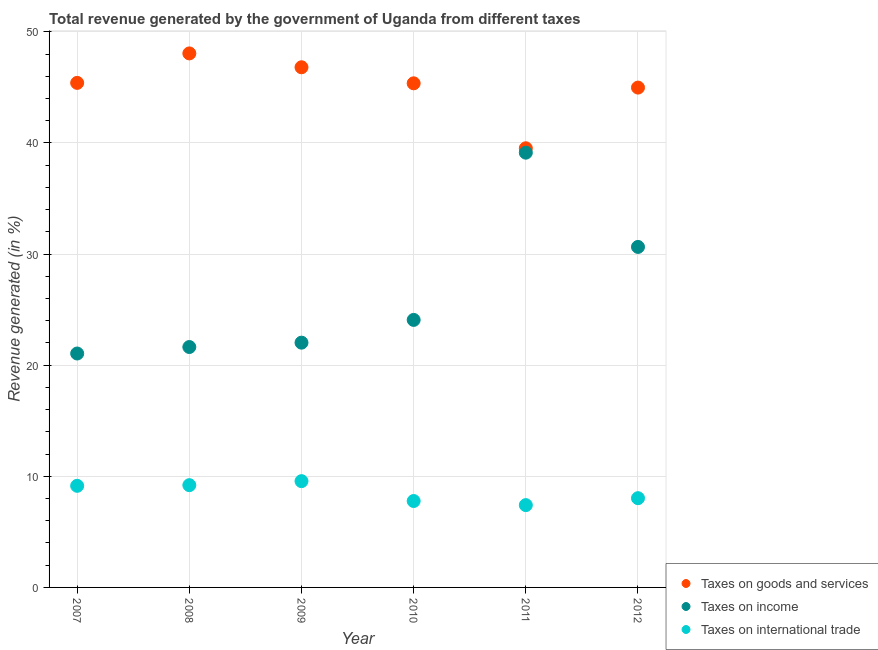Is the number of dotlines equal to the number of legend labels?
Provide a succinct answer. Yes. What is the percentage of revenue generated by taxes on income in 2010?
Make the answer very short. 24.07. Across all years, what is the maximum percentage of revenue generated by taxes on goods and services?
Offer a terse response. 48.06. Across all years, what is the minimum percentage of revenue generated by taxes on income?
Ensure brevity in your answer.  21.05. In which year was the percentage of revenue generated by taxes on income minimum?
Offer a very short reply. 2007. What is the total percentage of revenue generated by taxes on income in the graph?
Provide a succinct answer. 158.55. What is the difference between the percentage of revenue generated by taxes on income in 2007 and that in 2011?
Your answer should be compact. -18.07. What is the difference between the percentage of revenue generated by tax on international trade in 2011 and the percentage of revenue generated by taxes on goods and services in 2012?
Your answer should be compact. -37.57. What is the average percentage of revenue generated by tax on international trade per year?
Ensure brevity in your answer.  8.52. In the year 2010, what is the difference between the percentage of revenue generated by taxes on income and percentage of revenue generated by tax on international trade?
Your answer should be compact. 16.3. What is the ratio of the percentage of revenue generated by tax on international trade in 2007 to that in 2009?
Offer a terse response. 0.96. Is the percentage of revenue generated by taxes on goods and services in 2009 less than that in 2010?
Offer a terse response. No. Is the difference between the percentage of revenue generated by taxes on income in 2009 and 2011 greater than the difference between the percentage of revenue generated by tax on international trade in 2009 and 2011?
Ensure brevity in your answer.  No. What is the difference between the highest and the second highest percentage of revenue generated by tax on international trade?
Offer a terse response. 0.36. What is the difference between the highest and the lowest percentage of revenue generated by taxes on goods and services?
Provide a succinct answer. 8.54. In how many years, is the percentage of revenue generated by tax on international trade greater than the average percentage of revenue generated by tax on international trade taken over all years?
Your response must be concise. 3. Is it the case that in every year, the sum of the percentage of revenue generated by taxes on goods and services and percentage of revenue generated by taxes on income is greater than the percentage of revenue generated by tax on international trade?
Ensure brevity in your answer.  Yes. Does the percentage of revenue generated by taxes on income monotonically increase over the years?
Provide a short and direct response. No. Is the percentage of revenue generated by tax on international trade strictly greater than the percentage of revenue generated by taxes on income over the years?
Provide a succinct answer. No. Is the percentage of revenue generated by taxes on goods and services strictly less than the percentage of revenue generated by taxes on income over the years?
Offer a very short reply. No. How many dotlines are there?
Provide a short and direct response. 3. How many years are there in the graph?
Provide a short and direct response. 6. Does the graph contain any zero values?
Provide a short and direct response. No. Where does the legend appear in the graph?
Give a very brief answer. Bottom right. How are the legend labels stacked?
Keep it short and to the point. Vertical. What is the title of the graph?
Provide a short and direct response. Total revenue generated by the government of Uganda from different taxes. Does "Travel services" appear as one of the legend labels in the graph?
Your answer should be very brief. No. What is the label or title of the Y-axis?
Give a very brief answer. Revenue generated (in %). What is the Revenue generated (in %) of Taxes on goods and services in 2007?
Provide a succinct answer. 45.4. What is the Revenue generated (in %) in Taxes on income in 2007?
Make the answer very short. 21.05. What is the Revenue generated (in %) of Taxes on international trade in 2007?
Your response must be concise. 9.14. What is the Revenue generated (in %) of Taxes on goods and services in 2008?
Your answer should be very brief. 48.06. What is the Revenue generated (in %) in Taxes on income in 2008?
Offer a terse response. 21.63. What is the Revenue generated (in %) of Taxes on international trade in 2008?
Provide a succinct answer. 9.2. What is the Revenue generated (in %) of Taxes on goods and services in 2009?
Make the answer very short. 46.81. What is the Revenue generated (in %) of Taxes on income in 2009?
Offer a terse response. 22.03. What is the Revenue generated (in %) in Taxes on international trade in 2009?
Keep it short and to the point. 9.56. What is the Revenue generated (in %) of Taxes on goods and services in 2010?
Provide a short and direct response. 45.36. What is the Revenue generated (in %) in Taxes on income in 2010?
Provide a succinct answer. 24.07. What is the Revenue generated (in %) of Taxes on international trade in 2010?
Keep it short and to the point. 7.78. What is the Revenue generated (in %) of Taxes on goods and services in 2011?
Your answer should be compact. 39.52. What is the Revenue generated (in %) of Taxes on income in 2011?
Ensure brevity in your answer.  39.12. What is the Revenue generated (in %) in Taxes on international trade in 2011?
Ensure brevity in your answer.  7.41. What is the Revenue generated (in %) in Taxes on goods and services in 2012?
Provide a succinct answer. 44.98. What is the Revenue generated (in %) in Taxes on income in 2012?
Give a very brief answer. 30.64. What is the Revenue generated (in %) of Taxes on international trade in 2012?
Your response must be concise. 8.03. Across all years, what is the maximum Revenue generated (in %) of Taxes on goods and services?
Make the answer very short. 48.06. Across all years, what is the maximum Revenue generated (in %) in Taxes on income?
Your answer should be compact. 39.12. Across all years, what is the maximum Revenue generated (in %) of Taxes on international trade?
Your response must be concise. 9.56. Across all years, what is the minimum Revenue generated (in %) of Taxes on goods and services?
Your answer should be compact. 39.52. Across all years, what is the minimum Revenue generated (in %) in Taxes on income?
Your response must be concise. 21.05. Across all years, what is the minimum Revenue generated (in %) of Taxes on international trade?
Keep it short and to the point. 7.41. What is the total Revenue generated (in %) of Taxes on goods and services in the graph?
Offer a terse response. 270.13. What is the total Revenue generated (in %) in Taxes on income in the graph?
Offer a terse response. 158.55. What is the total Revenue generated (in %) of Taxes on international trade in the graph?
Ensure brevity in your answer.  51.12. What is the difference between the Revenue generated (in %) in Taxes on goods and services in 2007 and that in 2008?
Provide a short and direct response. -2.65. What is the difference between the Revenue generated (in %) in Taxes on income in 2007 and that in 2008?
Make the answer very short. -0.58. What is the difference between the Revenue generated (in %) in Taxes on international trade in 2007 and that in 2008?
Offer a terse response. -0.06. What is the difference between the Revenue generated (in %) of Taxes on goods and services in 2007 and that in 2009?
Provide a short and direct response. -1.4. What is the difference between the Revenue generated (in %) in Taxes on income in 2007 and that in 2009?
Give a very brief answer. -0.98. What is the difference between the Revenue generated (in %) of Taxes on international trade in 2007 and that in 2009?
Give a very brief answer. -0.42. What is the difference between the Revenue generated (in %) in Taxes on goods and services in 2007 and that in 2010?
Offer a terse response. 0.04. What is the difference between the Revenue generated (in %) in Taxes on income in 2007 and that in 2010?
Offer a very short reply. -3.02. What is the difference between the Revenue generated (in %) of Taxes on international trade in 2007 and that in 2010?
Provide a short and direct response. 1.37. What is the difference between the Revenue generated (in %) in Taxes on goods and services in 2007 and that in 2011?
Your answer should be compact. 5.89. What is the difference between the Revenue generated (in %) of Taxes on income in 2007 and that in 2011?
Offer a very short reply. -18.07. What is the difference between the Revenue generated (in %) in Taxes on international trade in 2007 and that in 2011?
Your answer should be very brief. 1.74. What is the difference between the Revenue generated (in %) in Taxes on goods and services in 2007 and that in 2012?
Ensure brevity in your answer.  0.42. What is the difference between the Revenue generated (in %) in Taxes on income in 2007 and that in 2012?
Offer a terse response. -9.59. What is the difference between the Revenue generated (in %) of Taxes on international trade in 2007 and that in 2012?
Provide a succinct answer. 1.11. What is the difference between the Revenue generated (in %) of Taxes on goods and services in 2008 and that in 2009?
Provide a short and direct response. 1.25. What is the difference between the Revenue generated (in %) in Taxes on income in 2008 and that in 2009?
Offer a very short reply. -0.39. What is the difference between the Revenue generated (in %) of Taxes on international trade in 2008 and that in 2009?
Your answer should be compact. -0.36. What is the difference between the Revenue generated (in %) in Taxes on goods and services in 2008 and that in 2010?
Your answer should be compact. 2.69. What is the difference between the Revenue generated (in %) in Taxes on income in 2008 and that in 2010?
Keep it short and to the point. -2.44. What is the difference between the Revenue generated (in %) of Taxes on international trade in 2008 and that in 2010?
Provide a succinct answer. 1.43. What is the difference between the Revenue generated (in %) in Taxes on goods and services in 2008 and that in 2011?
Offer a terse response. 8.54. What is the difference between the Revenue generated (in %) in Taxes on income in 2008 and that in 2011?
Your answer should be very brief. -17.49. What is the difference between the Revenue generated (in %) of Taxes on international trade in 2008 and that in 2011?
Offer a very short reply. 1.8. What is the difference between the Revenue generated (in %) of Taxes on goods and services in 2008 and that in 2012?
Offer a terse response. 3.08. What is the difference between the Revenue generated (in %) in Taxes on income in 2008 and that in 2012?
Offer a terse response. -9.01. What is the difference between the Revenue generated (in %) of Taxes on international trade in 2008 and that in 2012?
Provide a succinct answer. 1.17. What is the difference between the Revenue generated (in %) in Taxes on goods and services in 2009 and that in 2010?
Provide a succinct answer. 1.44. What is the difference between the Revenue generated (in %) in Taxes on income in 2009 and that in 2010?
Provide a short and direct response. -2.05. What is the difference between the Revenue generated (in %) in Taxes on international trade in 2009 and that in 2010?
Give a very brief answer. 1.79. What is the difference between the Revenue generated (in %) in Taxes on goods and services in 2009 and that in 2011?
Provide a short and direct response. 7.29. What is the difference between the Revenue generated (in %) of Taxes on income in 2009 and that in 2011?
Provide a short and direct response. -17.1. What is the difference between the Revenue generated (in %) in Taxes on international trade in 2009 and that in 2011?
Your response must be concise. 2.16. What is the difference between the Revenue generated (in %) in Taxes on goods and services in 2009 and that in 2012?
Give a very brief answer. 1.83. What is the difference between the Revenue generated (in %) of Taxes on income in 2009 and that in 2012?
Provide a succinct answer. -8.62. What is the difference between the Revenue generated (in %) of Taxes on international trade in 2009 and that in 2012?
Your response must be concise. 1.53. What is the difference between the Revenue generated (in %) in Taxes on goods and services in 2010 and that in 2011?
Offer a very short reply. 5.85. What is the difference between the Revenue generated (in %) in Taxes on income in 2010 and that in 2011?
Your answer should be very brief. -15.05. What is the difference between the Revenue generated (in %) in Taxes on international trade in 2010 and that in 2011?
Your response must be concise. 0.37. What is the difference between the Revenue generated (in %) in Taxes on goods and services in 2010 and that in 2012?
Provide a short and direct response. 0.38. What is the difference between the Revenue generated (in %) of Taxes on income in 2010 and that in 2012?
Provide a short and direct response. -6.57. What is the difference between the Revenue generated (in %) in Taxes on international trade in 2010 and that in 2012?
Ensure brevity in your answer.  -0.26. What is the difference between the Revenue generated (in %) of Taxes on goods and services in 2011 and that in 2012?
Provide a short and direct response. -5.46. What is the difference between the Revenue generated (in %) of Taxes on income in 2011 and that in 2012?
Keep it short and to the point. 8.48. What is the difference between the Revenue generated (in %) in Taxes on international trade in 2011 and that in 2012?
Your answer should be very brief. -0.62. What is the difference between the Revenue generated (in %) of Taxes on goods and services in 2007 and the Revenue generated (in %) of Taxes on income in 2008?
Provide a succinct answer. 23.77. What is the difference between the Revenue generated (in %) of Taxes on goods and services in 2007 and the Revenue generated (in %) of Taxes on international trade in 2008?
Ensure brevity in your answer.  36.2. What is the difference between the Revenue generated (in %) in Taxes on income in 2007 and the Revenue generated (in %) in Taxes on international trade in 2008?
Offer a very short reply. 11.85. What is the difference between the Revenue generated (in %) of Taxes on goods and services in 2007 and the Revenue generated (in %) of Taxes on income in 2009?
Your response must be concise. 23.38. What is the difference between the Revenue generated (in %) in Taxes on goods and services in 2007 and the Revenue generated (in %) in Taxes on international trade in 2009?
Ensure brevity in your answer.  35.84. What is the difference between the Revenue generated (in %) in Taxes on income in 2007 and the Revenue generated (in %) in Taxes on international trade in 2009?
Give a very brief answer. 11.49. What is the difference between the Revenue generated (in %) in Taxes on goods and services in 2007 and the Revenue generated (in %) in Taxes on income in 2010?
Your answer should be very brief. 21.33. What is the difference between the Revenue generated (in %) of Taxes on goods and services in 2007 and the Revenue generated (in %) of Taxes on international trade in 2010?
Keep it short and to the point. 37.63. What is the difference between the Revenue generated (in %) in Taxes on income in 2007 and the Revenue generated (in %) in Taxes on international trade in 2010?
Ensure brevity in your answer.  13.27. What is the difference between the Revenue generated (in %) of Taxes on goods and services in 2007 and the Revenue generated (in %) of Taxes on income in 2011?
Provide a short and direct response. 6.28. What is the difference between the Revenue generated (in %) in Taxes on goods and services in 2007 and the Revenue generated (in %) in Taxes on international trade in 2011?
Give a very brief answer. 38. What is the difference between the Revenue generated (in %) of Taxes on income in 2007 and the Revenue generated (in %) of Taxes on international trade in 2011?
Make the answer very short. 13.64. What is the difference between the Revenue generated (in %) of Taxes on goods and services in 2007 and the Revenue generated (in %) of Taxes on income in 2012?
Your answer should be very brief. 14.76. What is the difference between the Revenue generated (in %) of Taxes on goods and services in 2007 and the Revenue generated (in %) of Taxes on international trade in 2012?
Ensure brevity in your answer.  37.37. What is the difference between the Revenue generated (in %) of Taxes on income in 2007 and the Revenue generated (in %) of Taxes on international trade in 2012?
Give a very brief answer. 13.02. What is the difference between the Revenue generated (in %) of Taxes on goods and services in 2008 and the Revenue generated (in %) of Taxes on income in 2009?
Your answer should be compact. 26.03. What is the difference between the Revenue generated (in %) of Taxes on goods and services in 2008 and the Revenue generated (in %) of Taxes on international trade in 2009?
Your answer should be very brief. 38.49. What is the difference between the Revenue generated (in %) in Taxes on income in 2008 and the Revenue generated (in %) in Taxes on international trade in 2009?
Keep it short and to the point. 12.07. What is the difference between the Revenue generated (in %) of Taxes on goods and services in 2008 and the Revenue generated (in %) of Taxes on income in 2010?
Make the answer very short. 23.98. What is the difference between the Revenue generated (in %) in Taxes on goods and services in 2008 and the Revenue generated (in %) in Taxes on international trade in 2010?
Provide a short and direct response. 40.28. What is the difference between the Revenue generated (in %) of Taxes on income in 2008 and the Revenue generated (in %) of Taxes on international trade in 2010?
Ensure brevity in your answer.  13.86. What is the difference between the Revenue generated (in %) of Taxes on goods and services in 2008 and the Revenue generated (in %) of Taxes on income in 2011?
Offer a very short reply. 8.93. What is the difference between the Revenue generated (in %) of Taxes on goods and services in 2008 and the Revenue generated (in %) of Taxes on international trade in 2011?
Ensure brevity in your answer.  40.65. What is the difference between the Revenue generated (in %) of Taxes on income in 2008 and the Revenue generated (in %) of Taxes on international trade in 2011?
Your answer should be compact. 14.23. What is the difference between the Revenue generated (in %) in Taxes on goods and services in 2008 and the Revenue generated (in %) in Taxes on income in 2012?
Keep it short and to the point. 17.41. What is the difference between the Revenue generated (in %) in Taxes on goods and services in 2008 and the Revenue generated (in %) in Taxes on international trade in 2012?
Your answer should be compact. 40.02. What is the difference between the Revenue generated (in %) in Taxes on income in 2008 and the Revenue generated (in %) in Taxes on international trade in 2012?
Ensure brevity in your answer.  13.6. What is the difference between the Revenue generated (in %) of Taxes on goods and services in 2009 and the Revenue generated (in %) of Taxes on income in 2010?
Your answer should be very brief. 22.73. What is the difference between the Revenue generated (in %) in Taxes on goods and services in 2009 and the Revenue generated (in %) in Taxes on international trade in 2010?
Your answer should be very brief. 39.03. What is the difference between the Revenue generated (in %) of Taxes on income in 2009 and the Revenue generated (in %) of Taxes on international trade in 2010?
Your response must be concise. 14.25. What is the difference between the Revenue generated (in %) in Taxes on goods and services in 2009 and the Revenue generated (in %) in Taxes on income in 2011?
Your response must be concise. 7.69. What is the difference between the Revenue generated (in %) in Taxes on goods and services in 2009 and the Revenue generated (in %) in Taxes on international trade in 2011?
Provide a short and direct response. 39.4. What is the difference between the Revenue generated (in %) in Taxes on income in 2009 and the Revenue generated (in %) in Taxes on international trade in 2011?
Offer a terse response. 14.62. What is the difference between the Revenue generated (in %) in Taxes on goods and services in 2009 and the Revenue generated (in %) in Taxes on income in 2012?
Your response must be concise. 16.17. What is the difference between the Revenue generated (in %) of Taxes on goods and services in 2009 and the Revenue generated (in %) of Taxes on international trade in 2012?
Your answer should be very brief. 38.78. What is the difference between the Revenue generated (in %) of Taxes on income in 2009 and the Revenue generated (in %) of Taxes on international trade in 2012?
Provide a short and direct response. 13.99. What is the difference between the Revenue generated (in %) of Taxes on goods and services in 2010 and the Revenue generated (in %) of Taxes on income in 2011?
Offer a very short reply. 6.24. What is the difference between the Revenue generated (in %) in Taxes on goods and services in 2010 and the Revenue generated (in %) in Taxes on international trade in 2011?
Ensure brevity in your answer.  37.96. What is the difference between the Revenue generated (in %) of Taxes on income in 2010 and the Revenue generated (in %) of Taxes on international trade in 2011?
Your answer should be very brief. 16.67. What is the difference between the Revenue generated (in %) in Taxes on goods and services in 2010 and the Revenue generated (in %) in Taxes on income in 2012?
Offer a very short reply. 14.72. What is the difference between the Revenue generated (in %) in Taxes on goods and services in 2010 and the Revenue generated (in %) in Taxes on international trade in 2012?
Make the answer very short. 37.33. What is the difference between the Revenue generated (in %) in Taxes on income in 2010 and the Revenue generated (in %) in Taxes on international trade in 2012?
Offer a very short reply. 16.04. What is the difference between the Revenue generated (in %) of Taxes on goods and services in 2011 and the Revenue generated (in %) of Taxes on income in 2012?
Provide a short and direct response. 8.88. What is the difference between the Revenue generated (in %) of Taxes on goods and services in 2011 and the Revenue generated (in %) of Taxes on international trade in 2012?
Give a very brief answer. 31.49. What is the difference between the Revenue generated (in %) in Taxes on income in 2011 and the Revenue generated (in %) in Taxes on international trade in 2012?
Provide a short and direct response. 31.09. What is the average Revenue generated (in %) of Taxes on goods and services per year?
Your response must be concise. 45.02. What is the average Revenue generated (in %) in Taxes on income per year?
Offer a very short reply. 26.42. What is the average Revenue generated (in %) in Taxes on international trade per year?
Offer a terse response. 8.52. In the year 2007, what is the difference between the Revenue generated (in %) of Taxes on goods and services and Revenue generated (in %) of Taxes on income?
Your answer should be very brief. 24.35. In the year 2007, what is the difference between the Revenue generated (in %) in Taxes on goods and services and Revenue generated (in %) in Taxes on international trade?
Make the answer very short. 36.26. In the year 2007, what is the difference between the Revenue generated (in %) of Taxes on income and Revenue generated (in %) of Taxes on international trade?
Your answer should be compact. 11.91. In the year 2008, what is the difference between the Revenue generated (in %) in Taxes on goods and services and Revenue generated (in %) in Taxes on income?
Your response must be concise. 26.42. In the year 2008, what is the difference between the Revenue generated (in %) in Taxes on goods and services and Revenue generated (in %) in Taxes on international trade?
Offer a terse response. 38.85. In the year 2008, what is the difference between the Revenue generated (in %) in Taxes on income and Revenue generated (in %) in Taxes on international trade?
Ensure brevity in your answer.  12.43. In the year 2009, what is the difference between the Revenue generated (in %) in Taxes on goods and services and Revenue generated (in %) in Taxes on income?
Offer a very short reply. 24.78. In the year 2009, what is the difference between the Revenue generated (in %) of Taxes on goods and services and Revenue generated (in %) of Taxes on international trade?
Keep it short and to the point. 37.24. In the year 2009, what is the difference between the Revenue generated (in %) in Taxes on income and Revenue generated (in %) in Taxes on international trade?
Ensure brevity in your answer.  12.46. In the year 2010, what is the difference between the Revenue generated (in %) of Taxes on goods and services and Revenue generated (in %) of Taxes on income?
Give a very brief answer. 21.29. In the year 2010, what is the difference between the Revenue generated (in %) in Taxes on goods and services and Revenue generated (in %) in Taxes on international trade?
Give a very brief answer. 37.59. In the year 2010, what is the difference between the Revenue generated (in %) in Taxes on income and Revenue generated (in %) in Taxes on international trade?
Provide a succinct answer. 16.3. In the year 2011, what is the difference between the Revenue generated (in %) of Taxes on goods and services and Revenue generated (in %) of Taxes on income?
Provide a short and direct response. 0.4. In the year 2011, what is the difference between the Revenue generated (in %) in Taxes on goods and services and Revenue generated (in %) in Taxes on international trade?
Provide a short and direct response. 32.11. In the year 2011, what is the difference between the Revenue generated (in %) of Taxes on income and Revenue generated (in %) of Taxes on international trade?
Your answer should be compact. 31.72. In the year 2012, what is the difference between the Revenue generated (in %) in Taxes on goods and services and Revenue generated (in %) in Taxes on income?
Your answer should be compact. 14.34. In the year 2012, what is the difference between the Revenue generated (in %) in Taxes on goods and services and Revenue generated (in %) in Taxes on international trade?
Make the answer very short. 36.95. In the year 2012, what is the difference between the Revenue generated (in %) of Taxes on income and Revenue generated (in %) of Taxes on international trade?
Offer a very short reply. 22.61. What is the ratio of the Revenue generated (in %) in Taxes on goods and services in 2007 to that in 2008?
Provide a short and direct response. 0.94. What is the ratio of the Revenue generated (in %) of Taxes on goods and services in 2007 to that in 2009?
Provide a succinct answer. 0.97. What is the ratio of the Revenue generated (in %) in Taxes on income in 2007 to that in 2009?
Make the answer very short. 0.96. What is the ratio of the Revenue generated (in %) of Taxes on international trade in 2007 to that in 2009?
Offer a very short reply. 0.96. What is the ratio of the Revenue generated (in %) of Taxes on income in 2007 to that in 2010?
Your response must be concise. 0.87. What is the ratio of the Revenue generated (in %) of Taxes on international trade in 2007 to that in 2010?
Make the answer very short. 1.18. What is the ratio of the Revenue generated (in %) of Taxes on goods and services in 2007 to that in 2011?
Your answer should be compact. 1.15. What is the ratio of the Revenue generated (in %) in Taxes on income in 2007 to that in 2011?
Offer a very short reply. 0.54. What is the ratio of the Revenue generated (in %) of Taxes on international trade in 2007 to that in 2011?
Give a very brief answer. 1.23. What is the ratio of the Revenue generated (in %) of Taxes on goods and services in 2007 to that in 2012?
Your answer should be very brief. 1.01. What is the ratio of the Revenue generated (in %) in Taxes on income in 2007 to that in 2012?
Your answer should be compact. 0.69. What is the ratio of the Revenue generated (in %) of Taxes on international trade in 2007 to that in 2012?
Your answer should be compact. 1.14. What is the ratio of the Revenue generated (in %) in Taxes on goods and services in 2008 to that in 2009?
Provide a succinct answer. 1.03. What is the ratio of the Revenue generated (in %) in Taxes on income in 2008 to that in 2009?
Ensure brevity in your answer.  0.98. What is the ratio of the Revenue generated (in %) in Taxes on international trade in 2008 to that in 2009?
Make the answer very short. 0.96. What is the ratio of the Revenue generated (in %) of Taxes on goods and services in 2008 to that in 2010?
Offer a terse response. 1.06. What is the ratio of the Revenue generated (in %) in Taxes on income in 2008 to that in 2010?
Offer a very short reply. 0.9. What is the ratio of the Revenue generated (in %) in Taxes on international trade in 2008 to that in 2010?
Ensure brevity in your answer.  1.18. What is the ratio of the Revenue generated (in %) of Taxes on goods and services in 2008 to that in 2011?
Your response must be concise. 1.22. What is the ratio of the Revenue generated (in %) of Taxes on income in 2008 to that in 2011?
Give a very brief answer. 0.55. What is the ratio of the Revenue generated (in %) in Taxes on international trade in 2008 to that in 2011?
Provide a succinct answer. 1.24. What is the ratio of the Revenue generated (in %) of Taxes on goods and services in 2008 to that in 2012?
Ensure brevity in your answer.  1.07. What is the ratio of the Revenue generated (in %) in Taxes on income in 2008 to that in 2012?
Your answer should be very brief. 0.71. What is the ratio of the Revenue generated (in %) of Taxes on international trade in 2008 to that in 2012?
Ensure brevity in your answer.  1.15. What is the ratio of the Revenue generated (in %) of Taxes on goods and services in 2009 to that in 2010?
Give a very brief answer. 1.03. What is the ratio of the Revenue generated (in %) in Taxes on income in 2009 to that in 2010?
Provide a short and direct response. 0.91. What is the ratio of the Revenue generated (in %) in Taxes on international trade in 2009 to that in 2010?
Ensure brevity in your answer.  1.23. What is the ratio of the Revenue generated (in %) in Taxes on goods and services in 2009 to that in 2011?
Provide a short and direct response. 1.18. What is the ratio of the Revenue generated (in %) of Taxes on income in 2009 to that in 2011?
Provide a short and direct response. 0.56. What is the ratio of the Revenue generated (in %) in Taxes on international trade in 2009 to that in 2011?
Ensure brevity in your answer.  1.29. What is the ratio of the Revenue generated (in %) of Taxes on goods and services in 2009 to that in 2012?
Offer a very short reply. 1.04. What is the ratio of the Revenue generated (in %) of Taxes on income in 2009 to that in 2012?
Provide a short and direct response. 0.72. What is the ratio of the Revenue generated (in %) in Taxes on international trade in 2009 to that in 2012?
Offer a very short reply. 1.19. What is the ratio of the Revenue generated (in %) of Taxes on goods and services in 2010 to that in 2011?
Keep it short and to the point. 1.15. What is the ratio of the Revenue generated (in %) in Taxes on income in 2010 to that in 2011?
Give a very brief answer. 0.62. What is the ratio of the Revenue generated (in %) in Taxes on international trade in 2010 to that in 2011?
Ensure brevity in your answer.  1.05. What is the ratio of the Revenue generated (in %) in Taxes on goods and services in 2010 to that in 2012?
Provide a short and direct response. 1.01. What is the ratio of the Revenue generated (in %) of Taxes on income in 2010 to that in 2012?
Offer a very short reply. 0.79. What is the ratio of the Revenue generated (in %) of Taxes on international trade in 2010 to that in 2012?
Provide a succinct answer. 0.97. What is the ratio of the Revenue generated (in %) in Taxes on goods and services in 2011 to that in 2012?
Provide a short and direct response. 0.88. What is the ratio of the Revenue generated (in %) in Taxes on income in 2011 to that in 2012?
Keep it short and to the point. 1.28. What is the ratio of the Revenue generated (in %) in Taxes on international trade in 2011 to that in 2012?
Give a very brief answer. 0.92. What is the difference between the highest and the second highest Revenue generated (in %) in Taxes on goods and services?
Offer a terse response. 1.25. What is the difference between the highest and the second highest Revenue generated (in %) of Taxes on income?
Ensure brevity in your answer.  8.48. What is the difference between the highest and the second highest Revenue generated (in %) of Taxes on international trade?
Offer a very short reply. 0.36. What is the difference between the highest and the lowest Revenue generated (in %) in Taxes on goods and services?
Provide a short and direct response. 8.54. What is the difference between the highest and the lowest Revenue generated (in %) in Taxes on income?
Provide a succinct answer. 18.07. What is the difference between the highest and the lowest Revenue generated (in %) in Taxes on international trade?
Make the answer very short. 2.16. 